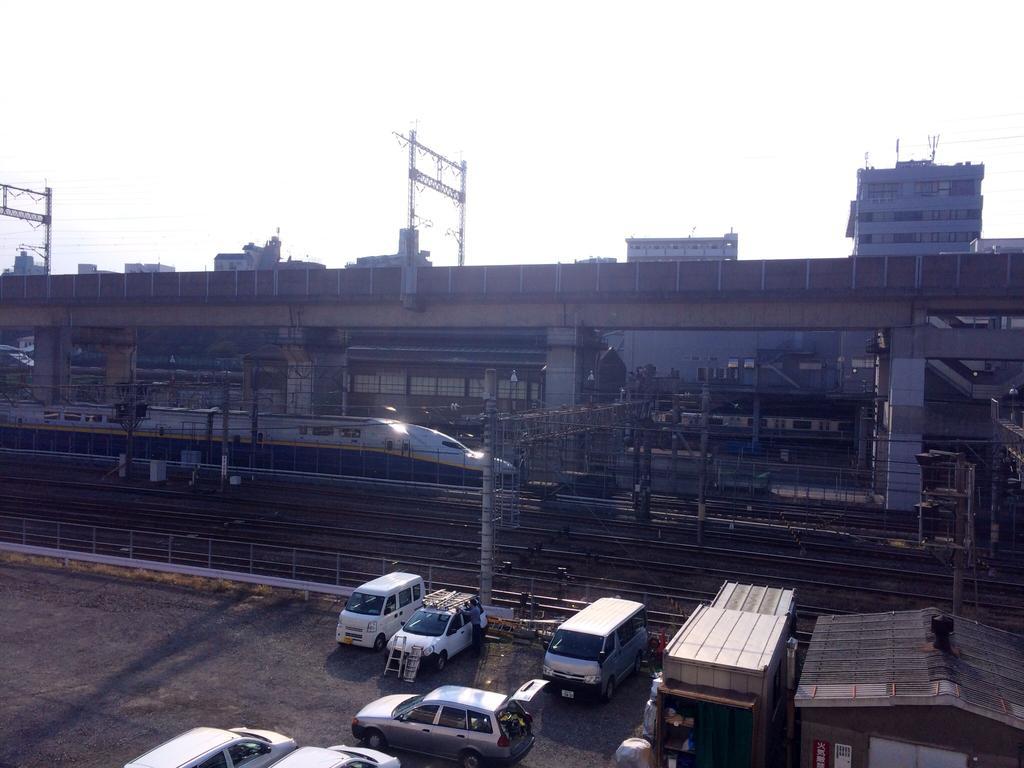Could you give a brief overview of what you see in this image? In this image we can see there is a train on the track. There are tracks, vehicles and sheds. There is a bridge. There are buildings and stands. In the background we can see the sky. 